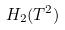<formula> <loc_0><loc_0><loc_500><loc_500>H _ { 2 } ( T ^ { 2 } )</formula> 